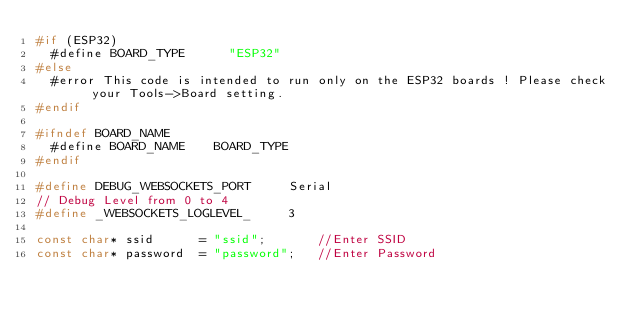<code> <loc_0><loc_0><loc_500><loc_500><_C_>#if (ESP32)
  #define BOARD_TYPE      "ESP32"
#else
  #error This code is intended to run only on the ESP32 boards ! Please check your Tools->Board setting.
#endif

#ifndef BOARD_NAME
  #define BOARD_NAME    BOARD_TYPE
#endif

#define DEBUG_WEBSOCKETS_PORT     Serial
// Debug Level from 0 to 4
#define _WEBSOCKETS_LOGLEVEL_     3

const char* ssid      = "ssid";       //Enter SSID
const char* password  = "password";   //Enter Password
</code> 